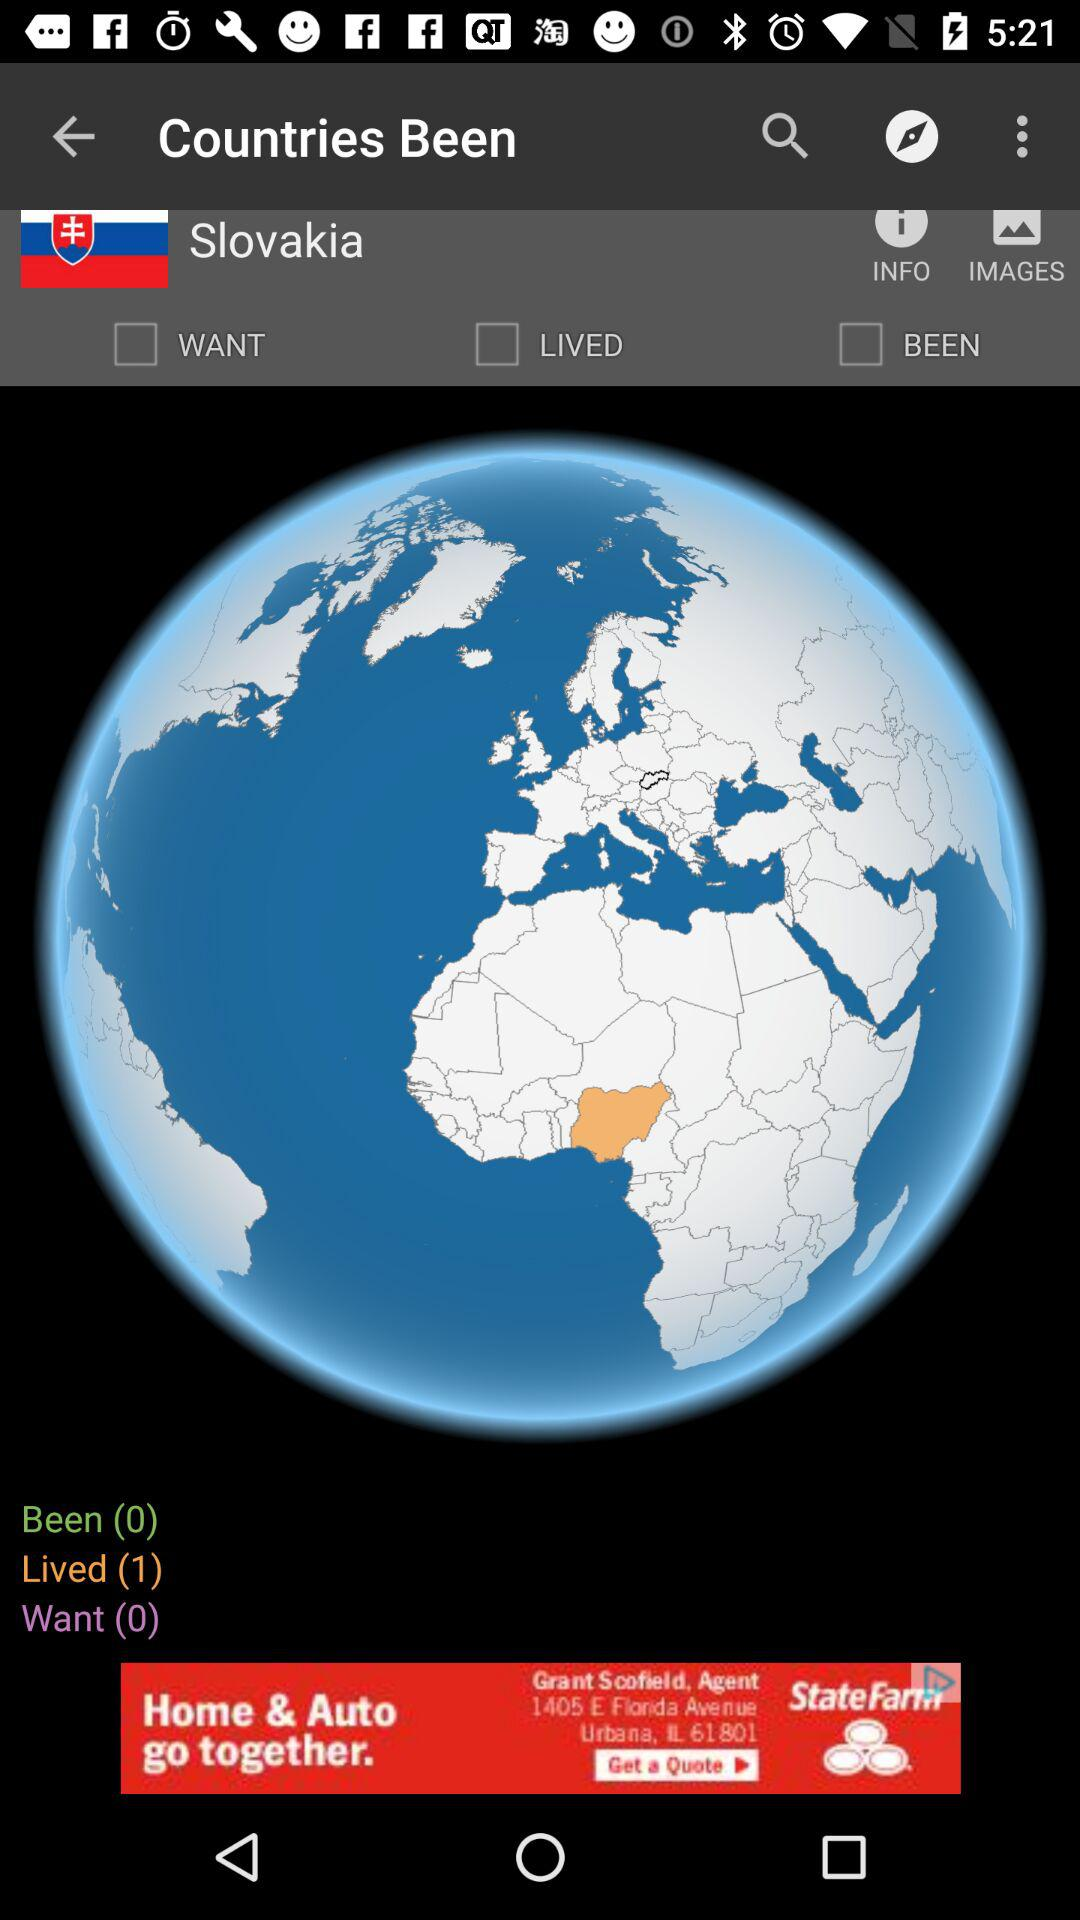How many countries have I been to?
Answer the question using a single word or phrase. 0 